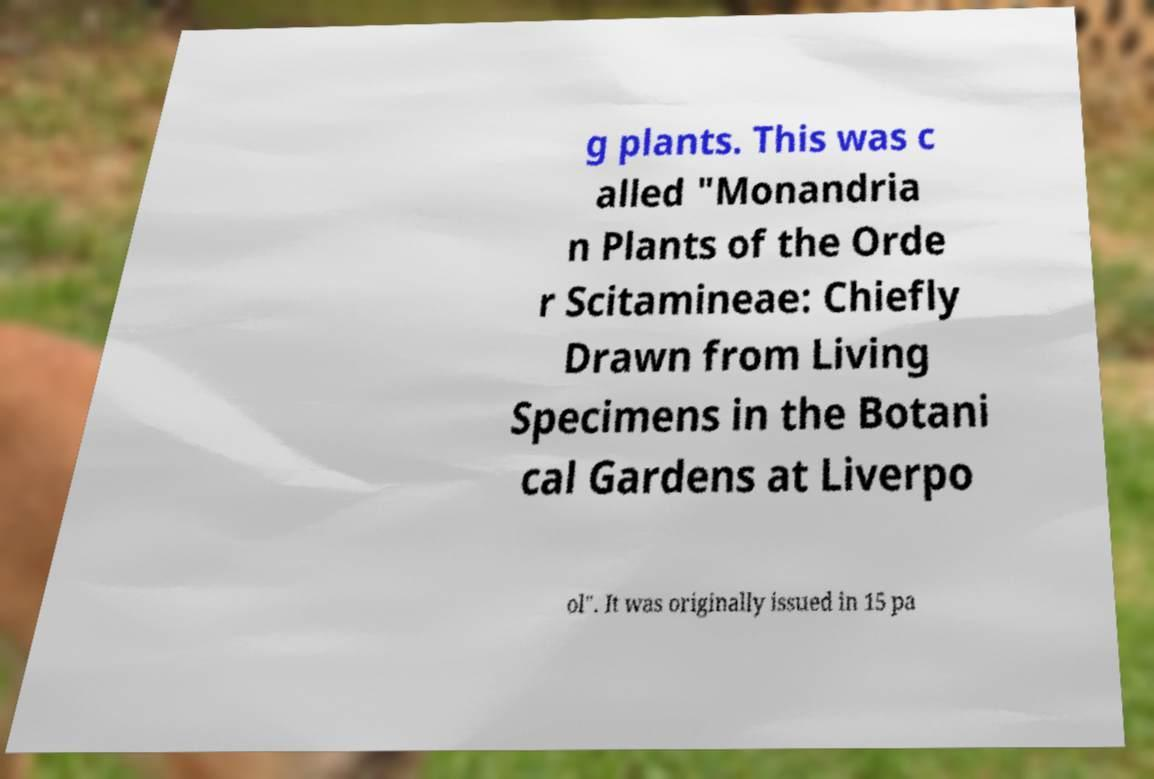Can you accurately transcribe the text from the provided image for me? g plants. This was c alled "Monandria n Plants of the Orde r Scitamineae: Chiefly Drawn from Living Specimens in the Botani cal Gardens at Liverpo ol". It was originally issued in 15 pa 